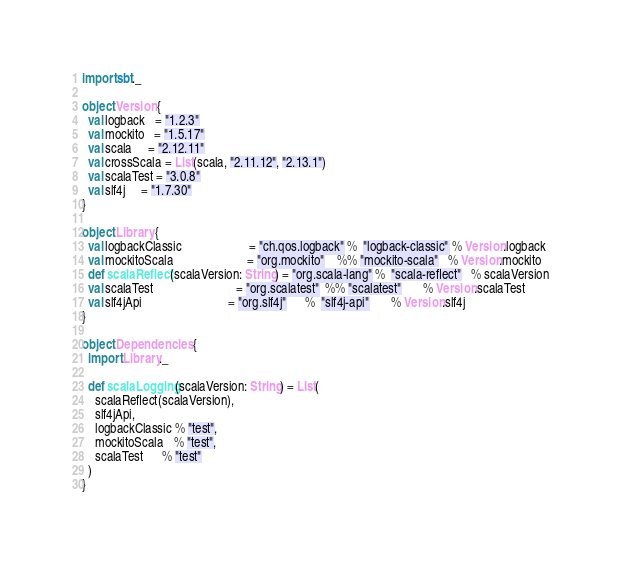<code> <loc_0><loc_0><loc_500><loc_500><_Scala_>import sbt._

object Version {
  val logback   = "1.2.3"
  val mockito   = "1.5.17"
  val scala     = "2.12.11"
  val crossScala = List(scala, "2.11.12", "2.13.1")
  val scalaTest = "3.0.8"
  val slf4j     = "1.7.30"
}

object Library {
  val logbackClassic                     = "ch.qos.logback" %  "logback-classic" % Version.logback
  val mockitoScala                       = "org.mockito"    %% "mockito-scala"   % Version.mockito
  def scalaReflect(scalaVersion: String) = "org.scala-lang" %  "scala-reflect"   % scalaVersion
  val scalaTest                          = "org.scalatest"  %% "scalatest"       % Version.scalaTest
  val slf4jApi                           = "org.slf4j"      %  "slf4j-api"       % Version.slf4j
}

object Dependencies {
  import Library._

  def scalaLogging(scalaVersion: String) = List(
    scalaReflect(scalaVersion),
    slf4jApi,
    logbackClassic % "test",
    mockitoScala   % "test",
    scalaTest      % "test"
  )
}
</code> 